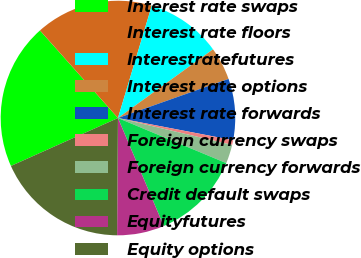Convert chart. <chart><loc_0><loc_0><loc_500><loc_500><pie_chart><fcel>Interest rate swaps<fcel>Interest rate floors<fcel>Interestratefutures<fcel>Interest rate options<fcel>Interest rate forwards<fcel>Foreign currency swaps<fcel>Foreign currency forwards<fcel>Credit default swaps<fcel>Equityfutures<fcel>Equity options<nl><fcel>20.12%<fcel>16.23%<fcel>10.39%<fcel>4.55%<fcel>8.44%<fcel>0.65%<fcel>2.6%<fcel>12.34%<fcel>6.5%<fcel>18.18%<nl></chart> 